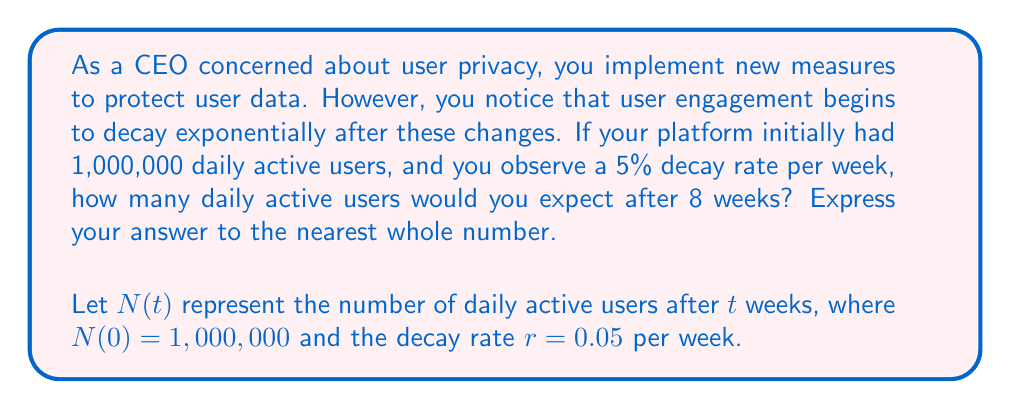Could you help me with this problem? To solve this problem, we'll use the exponential decay formula:

$$N(t) = N_0 \cdot (1-r)^t$$

Where:
$N(t)$ is the number of daily active users after $t$ weeks
$N_0$ is the initial number of daily active users (1,000,000)
$r$ is the decay rate per week (0.05 or 5%)
$t$ is the number of weeks (8)

Let's substitute these values into the formula:

$$N(8) = 1,000,000 \cdot (1-0.05)^8$$

Now, let's calculate step by step:

1) First, calculate $(1-0.05)^8$:
   $$(1-0.05)^8 = 0.95^8 \approx 0.6634$$

2) Multiply this by the initial number of users:
   $$1,000,000 \cdot 0.6634 \approx 663,400$$

3) Rounding to the nearest whole number:
   $$663,400 \approx 663,400$$

Therefore, after 8 weeks, you would expect approximately 663,400 daily active users.
Answer: 663,400 daily active users 